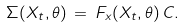Convert formula to latex. <formula><loc_0><loc_0><loc_500><loc_500>\Sigma ( X _ { t } , \theta ) \, = \, F _ { x } ( X _ { t } , \theta ) \, C .</formula> 